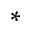<formula> <loc_0><loc_0><loc_500><loc_500>^ { * }</formula> 